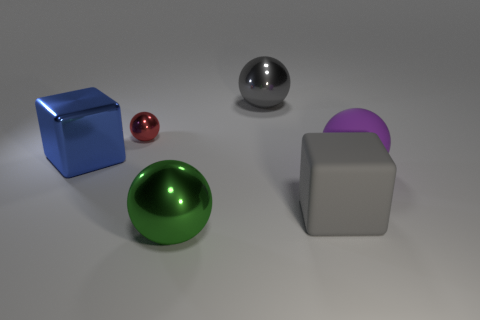Is there any other thing that is the same size as the red metallic ball?
Give a very brief answer. No. Is there a large ball of the same color as the big matte block?
Ensure brevity in your answer.  Yes. Is there a small blue cylinder?
Offer a terse response. No. Do the red object and the big purple matte thing have the same shape?
Offer a terse response. Yes. How many big things are red blocks or red metal spheres?
Your answer should be compact. 0. What color is the metallic block?
Offer a terse response. Blue. There is a metal thing that is right of the big ball on the left side of the big gray metal thing; what shape is it?
Provide a short and direct response. Sphere. Is there a big green ball made of the same material as the red ball?
Keep it short and to the point. Yes. There is a rubber object that is right of the gray matte thing; is its size the same as the large green ball?
Ensure brevity in your answer.  Yes. What number of green things are either small rubber objects or big balls?
Offer a very short reply. 1. 